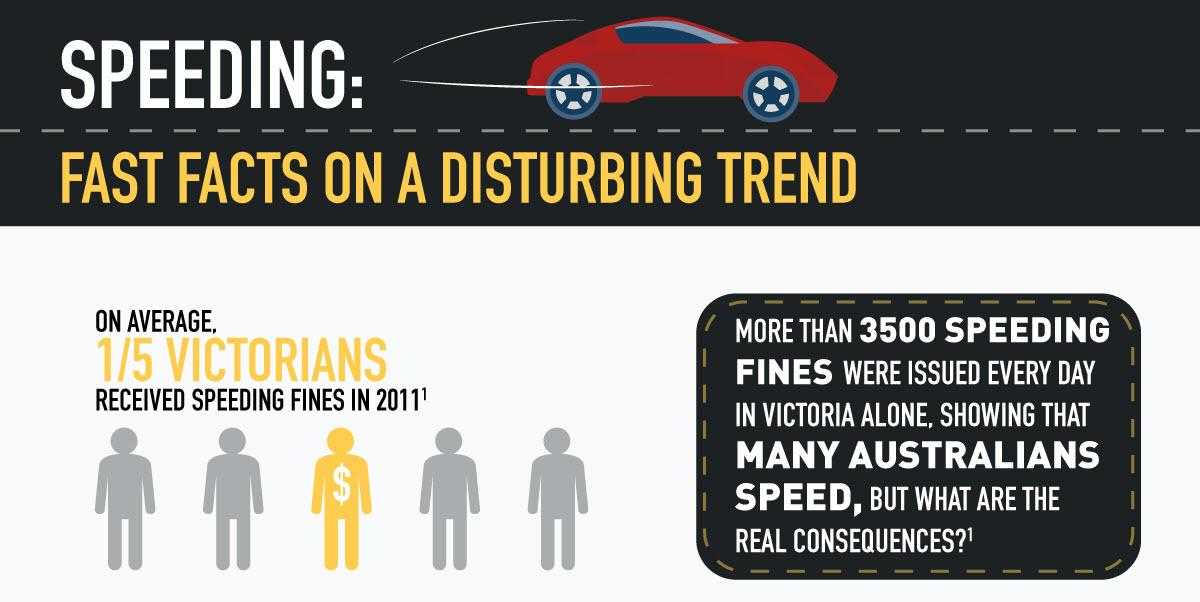Give some essential details in this illustration. Of the 4 person images shown, 4 were in gray color. In Victoria, 4 out of 5 people who were fined for speeding were penalized. On a daily basis, over 3,500 fines are issued in the state of Victoria. The color of the car depicted in the infographic is red. There is one depiction of a person with a dollar symbol in the infographic. 